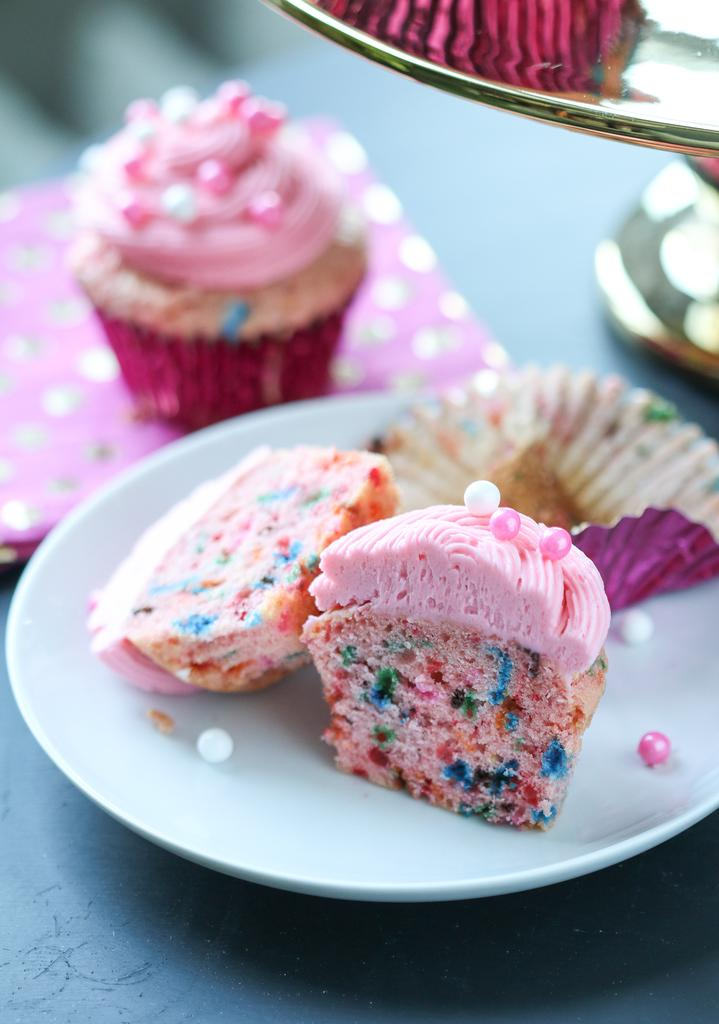What is on the plate that is visible in the image? There is food on a plate in the image. What type of food can be seen at the back of the image? There is a muffin at the back of the image. What else is in the image besides the plate and muffin? There is food in a bowl in the image. What surface is the plate and bowl placed on in the image? There is a table in the image. What letters are written on the muffin in the image? There are no letters written on the muffin in the image. What type of berry can be seen growing on the table in the image? There are no berries present in the image, and the table is not a plant or garden where berries would grow. 